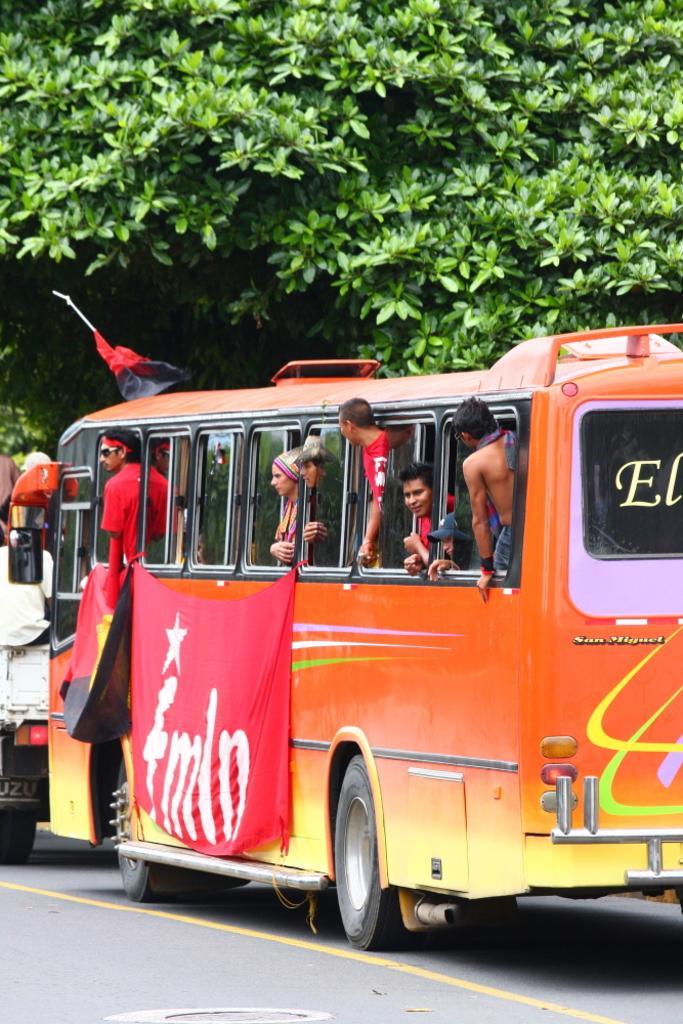In one or two sentences, can you explain what this image depicts? In this picture we can see few vehicles on the road, and we can find few people in the bus, in the background we can find few trees, and also we can see flags. 